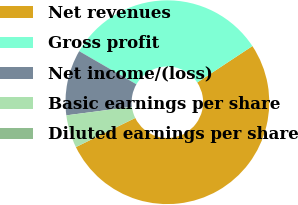Convert chart to OTSL. <chart><loc_0><loc_0><loc_500><loc_500><pie_chart><fcel>Net revenues<fcel>Gross profit<fcel>Net income/(loss)<fcel>Basic earnings per share<fcel>Diluted earnings per share<nl><fcel>52.03%<fcel>32.36%<fcel>10.41%<fcel>5.2%<fcel>0.0%<nl></chart> 